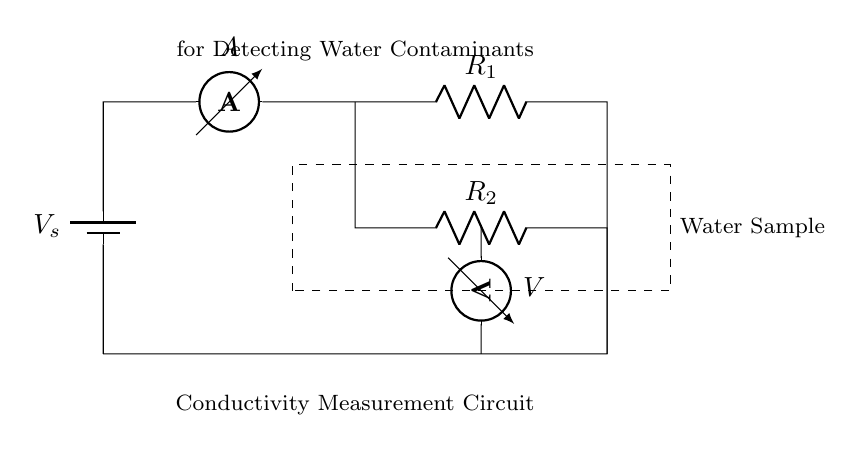What type of circuit is shown? This is a conductivity measurement circuit. The circuit components are arranged to measure the electrical conductivity of water, specifically designed for detecting contaminants.
Answer: Conductivity measurement circuit What does the battery represent in this circuit? The battery in this circuit provides the necessary voltage supply for measuring the current flowing through the resistors, which is essential for determining the conductivity of the water sample.
Answer: Voltage supply How many resistors are in the circuit? There are two resistors, R1 and R2, connected in parallel configuration. Each resistor has a role in the measurement of current and voltage related to the conductivity of the water sample.
Answer: Two What is the purpose of the ammeter in this circuit? The purpose of the ammeter is to measure the current flowing through the circuit. In the context of this conductivity measurement circuit, it provides information about the flow of charge, which can be correlated to the conductivity level of the water.
Answer: Measure current What does the voltmeter measure in this circuit? The voltmeter measures the voltage across one of the resistors in the circuit, which, along with the current measurement, allows for the calculation of the water's electrical conductivity based on Ohm's law.
Answer: Voltage across resistor What formula can be used to find the total current in the circuit? The total current in a current divider circuit can be found using the formula: total current equals the voltage divided by the equivalent resistance of the resistors. This helps in understanding how the total current is divided among resistors and the water sample.
Answer: Total current = voltage / equivalent resistance How is the water sample represented in the circuit? The water sample is represented by the dashed rectangle labeled "Water Sample" in the diagram. This indicates the section of the circuit where the conductivity will be specifically measured to assess quality and potential contamination.
Answer: Rectangle 